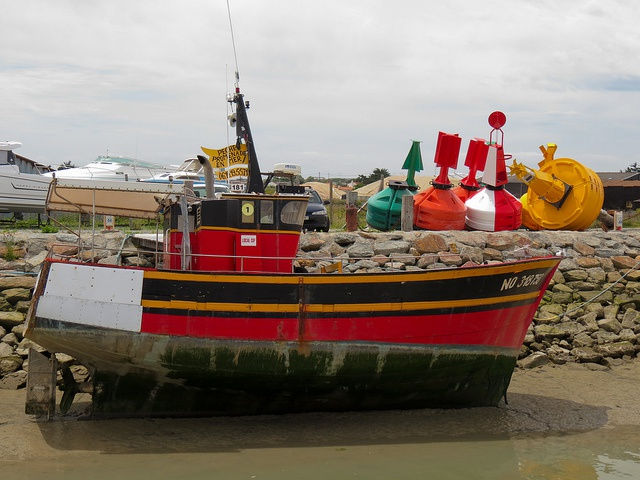Describe the objects in this image and their specific colors. I can see boat in lightgray, black, maroon, and darkgray tones, boat in lightgray, darkgray, tan, and gray tones, and car in lightgray, black, gray, darkgray, and olive tones in this image. 